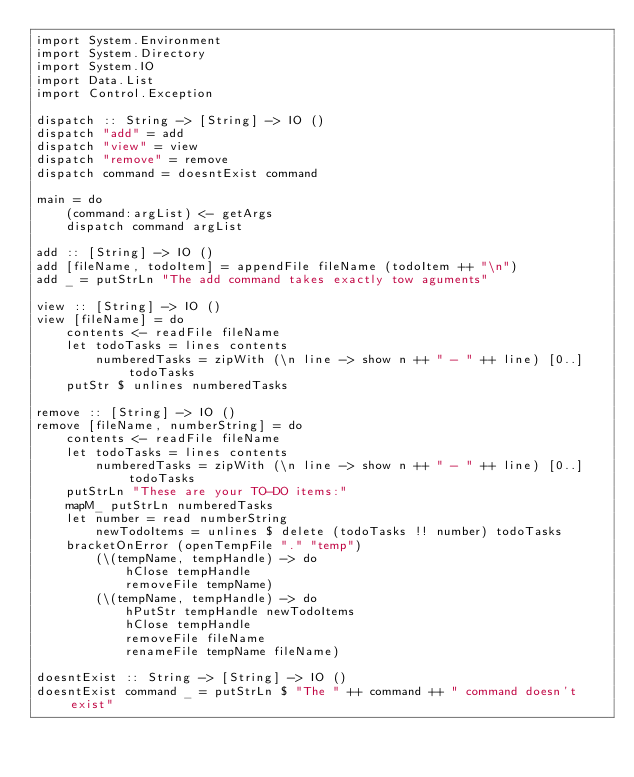<code> <loc_0><loc_0><loc_500><loc_500><_Haskell_>import System.Environment
import System.Directory
import System.IO
import Data.List
import Control.Exception

dispatch :: String -> [String] -> IO ()
dispatch "add" = add
dispatch "view" = view
dispatch "remove" = remove
dispatch command = doesntExist command

main = do
    (command:argList) <- getArgs
    dispatch command argList

add :: [String] -> IO ()
add [fileName, todoItem] = appendFile fileName (todoItem ++ "\n")
add _ = putStrLn "The add command takes exactly tow aguments"

view :: [String] -> IO ()
view [fileName] = do
    contents <- readFile fileName
    let todoTasks = lines contents
        numberedTasks = zipWith (\n line -> show n ++ " - " ++ line) [0..] todoTasks
    putStr $ unlines numberedTasks

remove :: [String] -> IO ()
remove [fileName, numberString] = do
    contents <- readFile fileName
    let todoTasks = lines contents
        numberedTasks = zipWith (\n line -> show n ++ " - " ++ line) [0..] todoTasks
    putStrLn "These are your TO-DO items:"
    mapM_ putStrLn numberedTasks
    let number = read numberString
        newTodoItems = unlines $ delete (todoTasks !! number) todoTasks
    bracketOnError (openTempFile "." "temp")
        (\(tempName, tempHandle) -> do
            hClose tempHandle
            removeFile tempName)
        (\(tempName, tempHandle) -> do
            hPutStr tempHandle newTodoItems
            hClose tempHandle
            removeFile fileName
            renameFile tempName fileName)

doesntExist :: String -> [String] -> IO ()
doesntExist command _ = putStrLn $ "The " ++ command ++ " command doesn't exist"</code> 